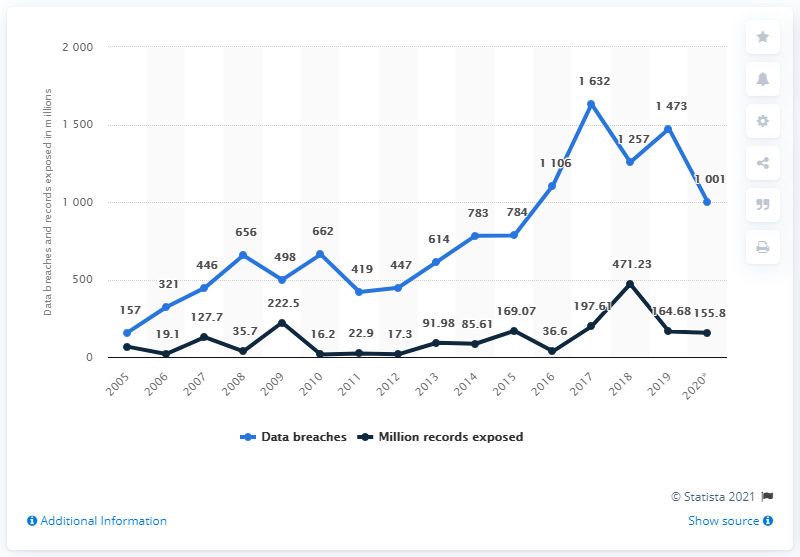Mention a couple of crucial points in this snapshot. The data breaches and records exposed in 2005 had the closest values compared to other years. In 2020, there were 1,001 data breaches in the United States. In 2020, an estimated 155.8 million people in the United States were affected by data exposures. The sum of the two line peaks is 2103.23. 